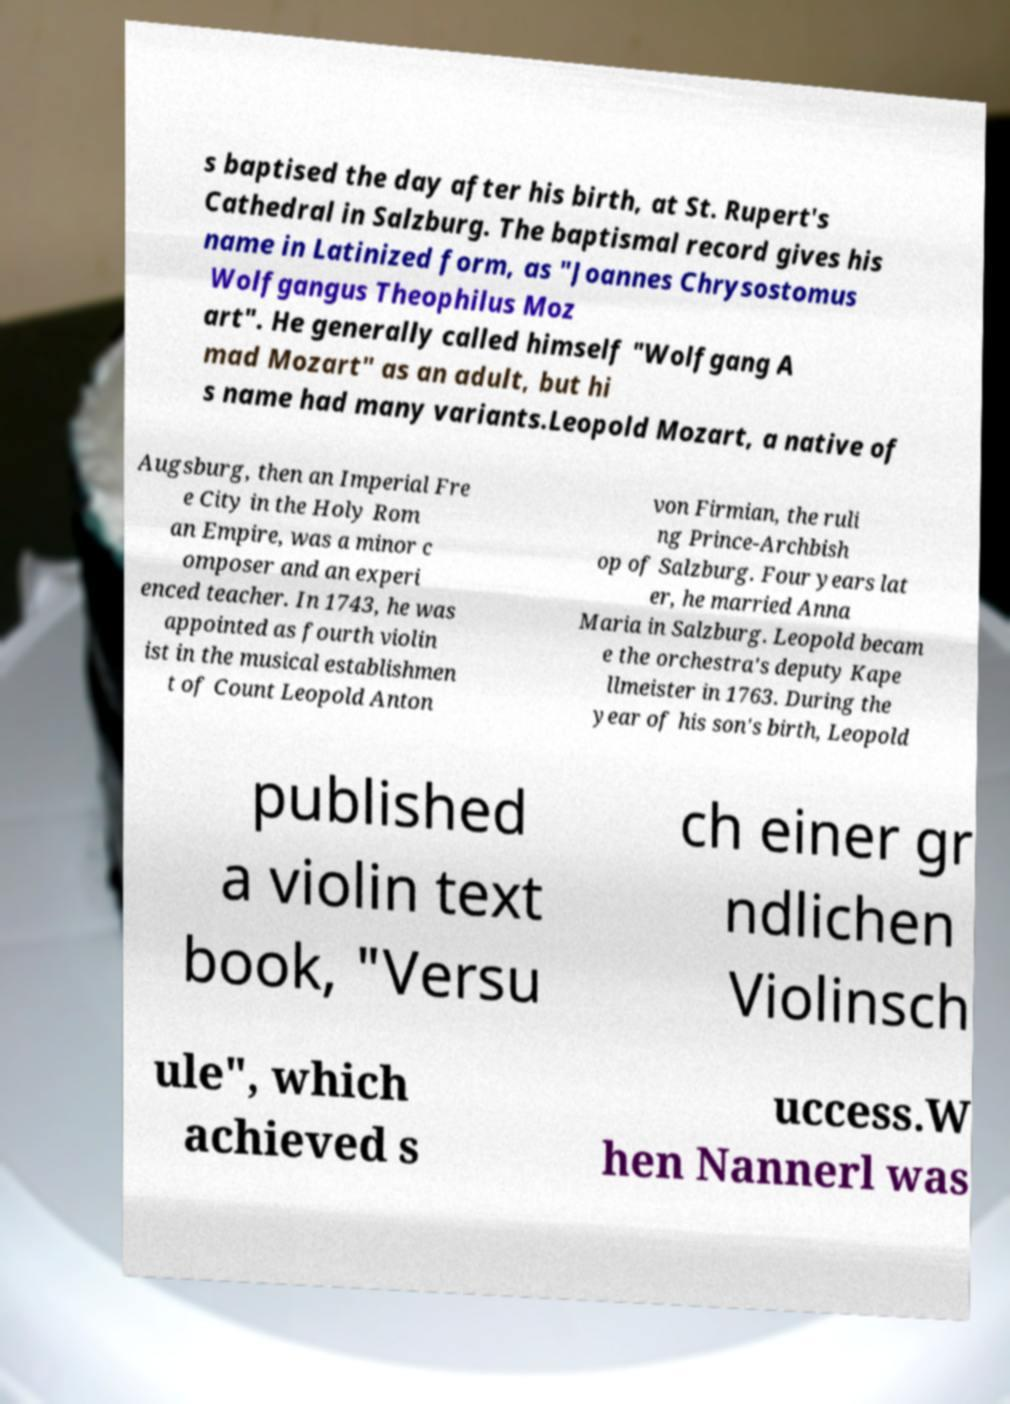What messages or text are displayed in this image? I need them in a readable, typed format. s baptised the day after his birth, at St. Rupert's Cathedral in Salzburg. The baptismal record gives his name in Latinized form, as "Joannes Chrysostomus Wolfgangus Theophilus Moz art". He generally called himself "Wolfgang A mad Mozart" as an adult, but hi s name had many variants.Leopold Mozart, a native of Augsburg, then an Imperial Fre e City in the Holy Rom an Empire, was a minor c omposer and an experi enced teacher. In 1743, he was appointed as fourth violin ist in the musical establishmen t of Count Leopold Anton von Firmian, the ruli ng Prince-Archbish op of Salzburg. Four years lat er, he married Anna Maria in Salzburg. Leopold becam e the orchestra's deputy Kape llmeister in 1763. During the year of his son's birth, Leopold published a violin text book, "Versu ch einer gr ndlichen Violinsch ule", which achieved s uccess.W hen Nannerl was 